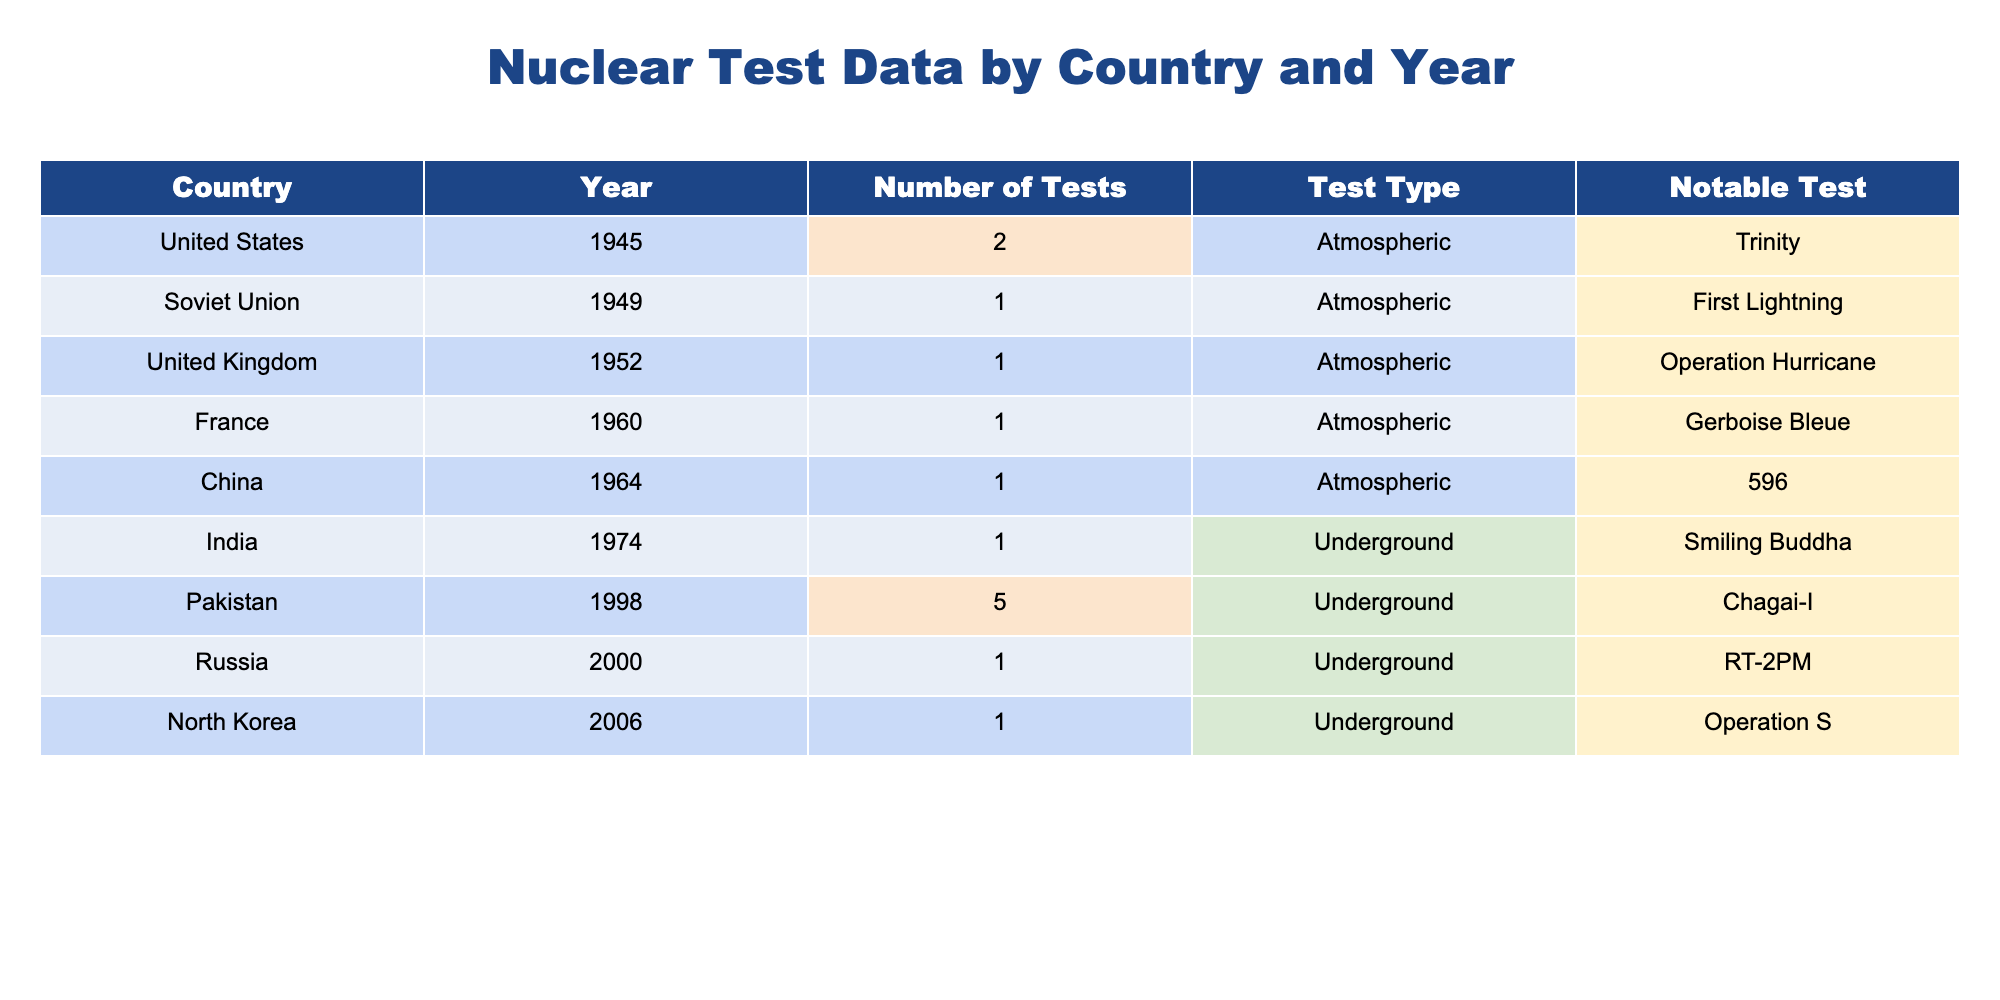What country conducted the first nuclear test? According to the table, the first nuclear test was conducted by the United States in 1945, marked by the notable test "Trinity".
Answer: United States How many atmospheric tests were conducted by the Soviet Union? The table shows that the Soviet Union conducted only 1 atmospheric test in 1949.
Answer: 1 Which country has the highest number of nuclear tests listed in the table? By reviewing the "Number of Tests" column, Pakistan conducted the highest amount with 5 tests in 1998.
Answer: Pakistan What was the notable test performed by China in 1964? The table indicates that China's notable test in 1964 was the test labeled as "596".
Answer: 596 Did any country conduct underground tests in the 2000s? By scanning the years listed, Russia performed an underground test in 2000, as indicated in the table.
Answer: Yes How many countries conducted nuclear tests in the 1950s? Referring to the years in the table, the United Kingdom (1952) and France (1960) conducted tests in the 1950s, amounting to 2 countries total.
Answer: 2 What is the average number of tests conducted by the countries listed in the table? Summing the number of tests (2 + 1 + 1 + 1 + 1 + 1 + 5 + 1 + 1) gives 13 total tests, and since there are 9 countries, the average is 13/9 ≈ 1.44.
Answer: Approximately 1.44 Which country performed an underground test that is not Russia? The table shows that Pakistan and India also performed underground tests, specifically Pakistan in 1998 (Chagai-I) and India in 1974 (Smiling Buddha).
Answer: Pakistan and India Is the notable test “Operation Hurricane” conducted by a country that tested after 1950? According to the table, "Operation Hurricane" was conducted by the United Kingdom in 1952, which is before 1950. Hence, the statement is false.
Answer: No How many countries conducted only one nuclear test according to the table? By inspecting the number of tests, the United States, Soviet Union, United Kingdom, France, China, India, Russia, and North Korea each conducted only one test, totaling 8 countries.
Answer: 8 